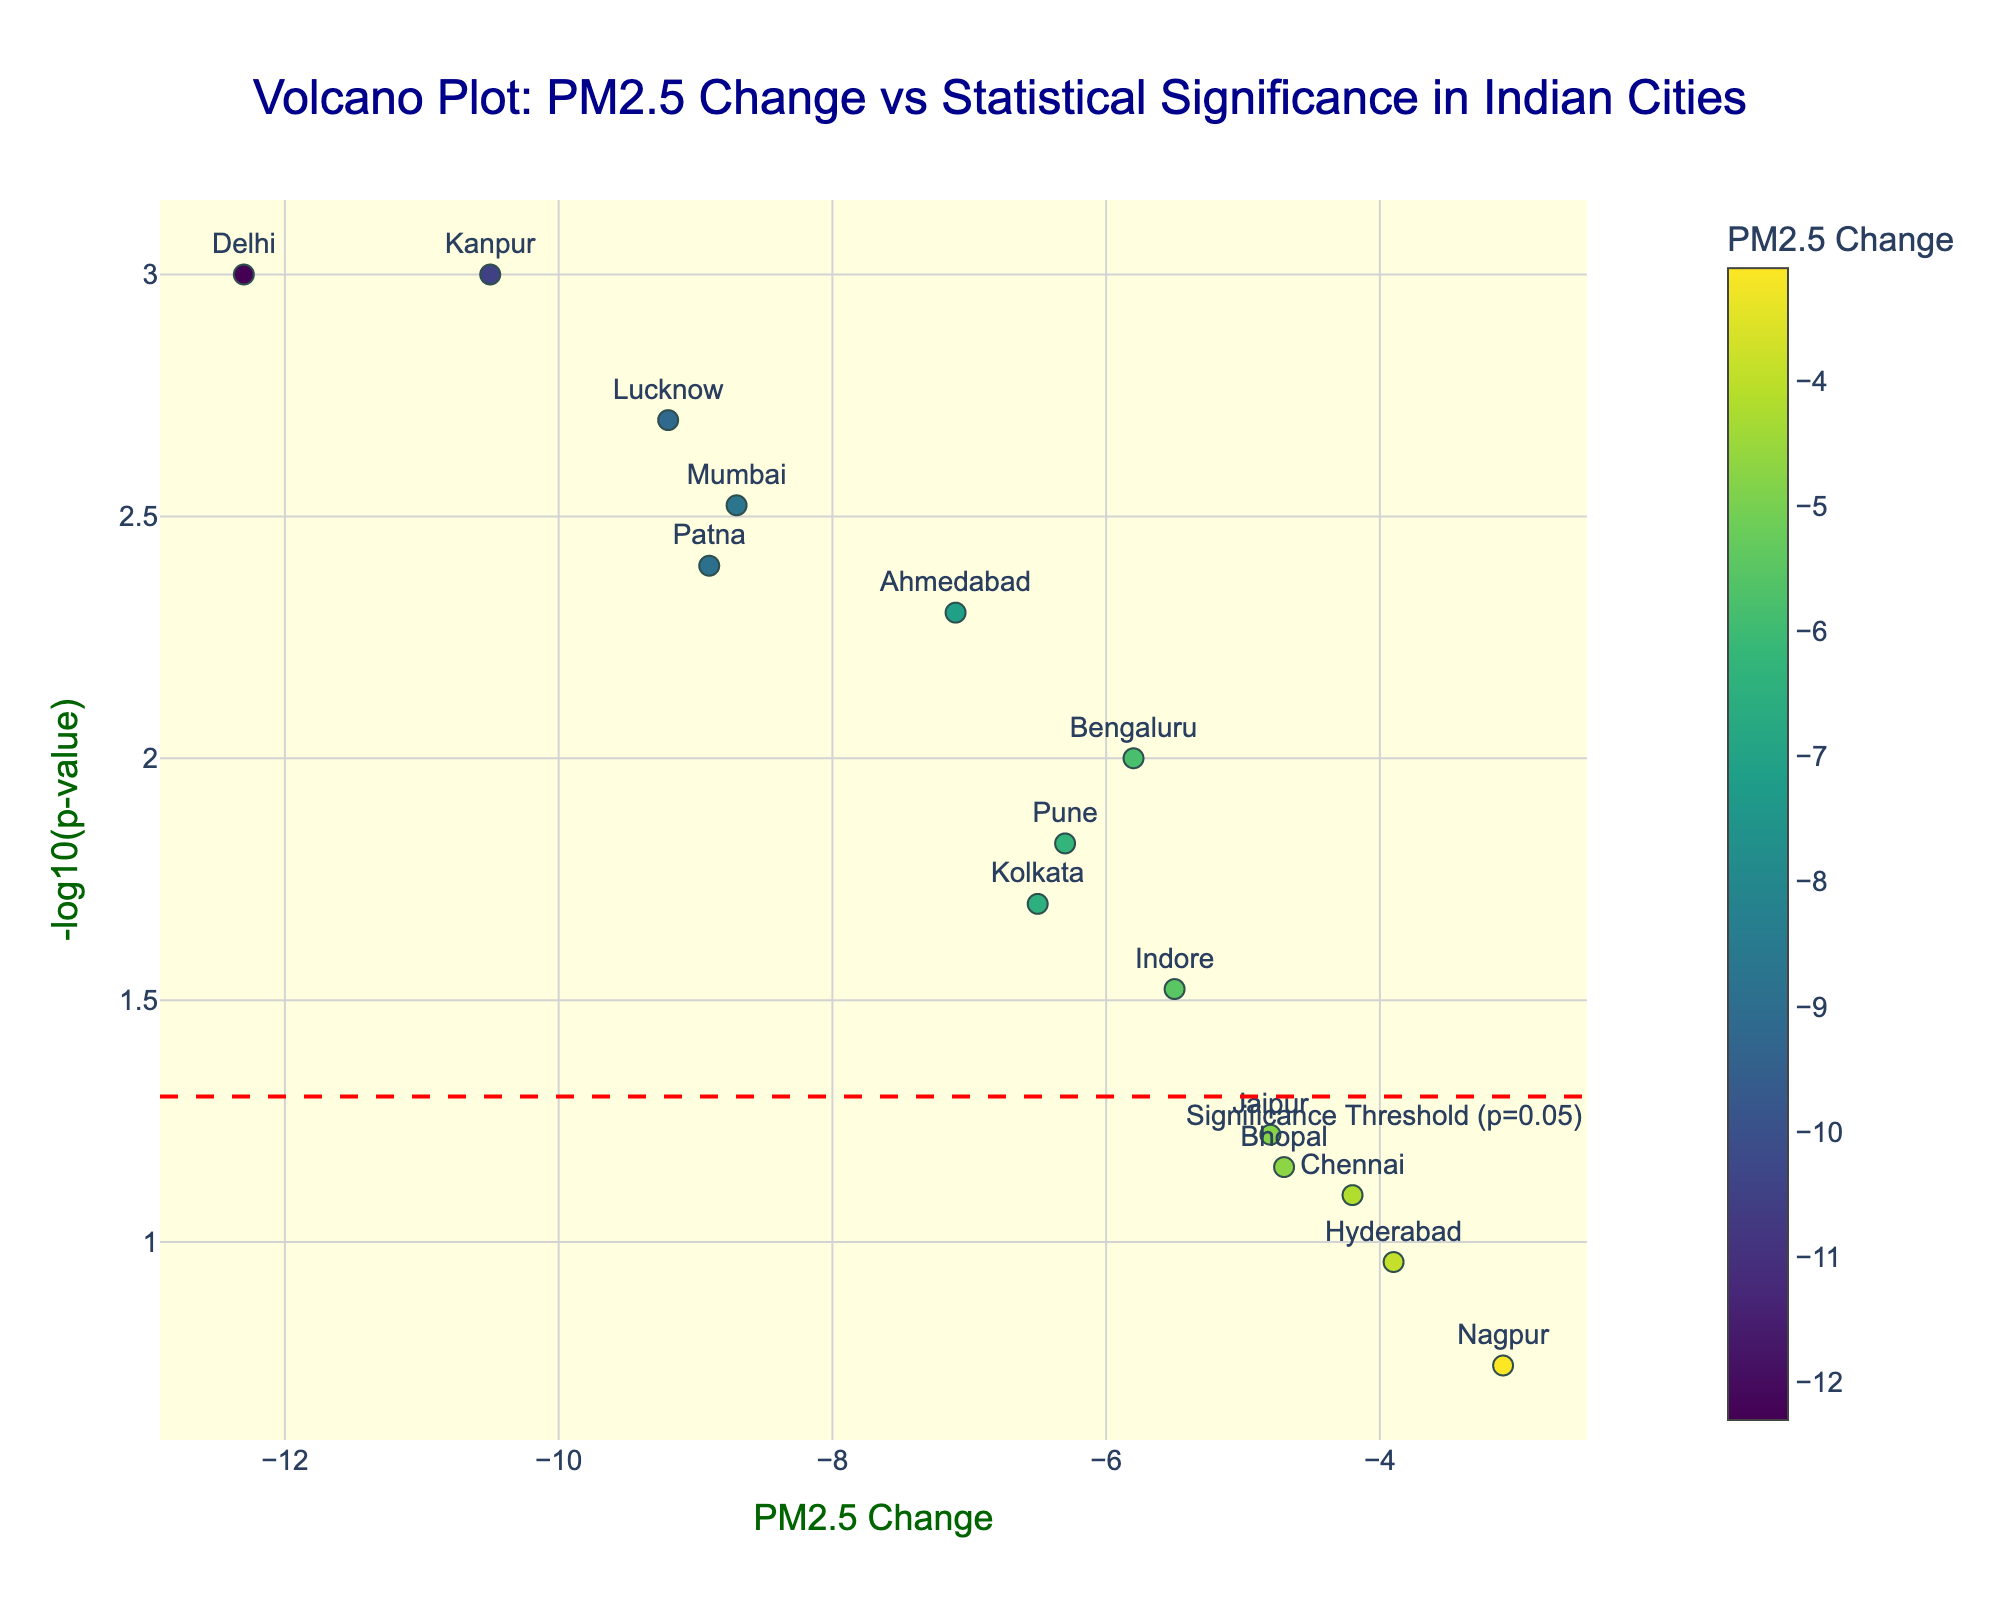Which city shows the most significant change in PM2.5 levels? The city with the most significant change would have the highest -log10(p-value). From the figure, this is indicated by the highest point on the vertical axis.
Answer: Delhi and Kanpur What is the PM2.5 change for Mumbai? Look for the label "Mumbai" on the plot and check its position on the x-axis for PM2.5 Change value.
Answer: -8.7 How many cities exhibited a significant change in PM2.5 levels? These cities will be above the horizontal significance threshold line (red dashed line). Count the number of points above this threshold.
Answer: 10 cities Did Chennai show a significant change in PM2.5 levels? Check if Chennai's data point is above or below the significance threshold line - the red dashed line.
Answer: No Which city experienced the smallest PM2.5 change? Find the data point that is farthest to the right or the left along the x-axis without taking the direction into account.
Answer: Nagpur How do the PM2.5 changes for Delhi and Lucknow compare? Check the positions of Delhi and Lucknow along the x-axis. They both have negative changes; compare the numeric values.
Answer: Delhi has a larger reduction than Lucknow Is there a general trend between the magnitude of PM2.5 change and statistical significance? Look for any pattern or correlation between the magnitude of PM2.5 change (x-axis) and the statistical significance (-log10(p-value), y-axis).
Answer: Cities with larger PM2.5 reductions tend to show higher statistical significance What's the most common range of PM2.5 change among the cities? Observe the distribution of points along the x-axis to identify where most points are clustered.
Answer: Between -6 and -10 Which city had the highest p-value, and did it show a significant PM2.5 change? The highest p-value corresponds to the lowest -log10(p-value). Check if the point is above the significance threshold line.
Answer: Nagpur, and it did not show a significant change Between Kolkata and Ahmedabad, which city had a more significant p-value? Compare the -log10(p-value) for both cities, with a higher y-value indicating a more significant p-value.
Answer: Ahmedabad 